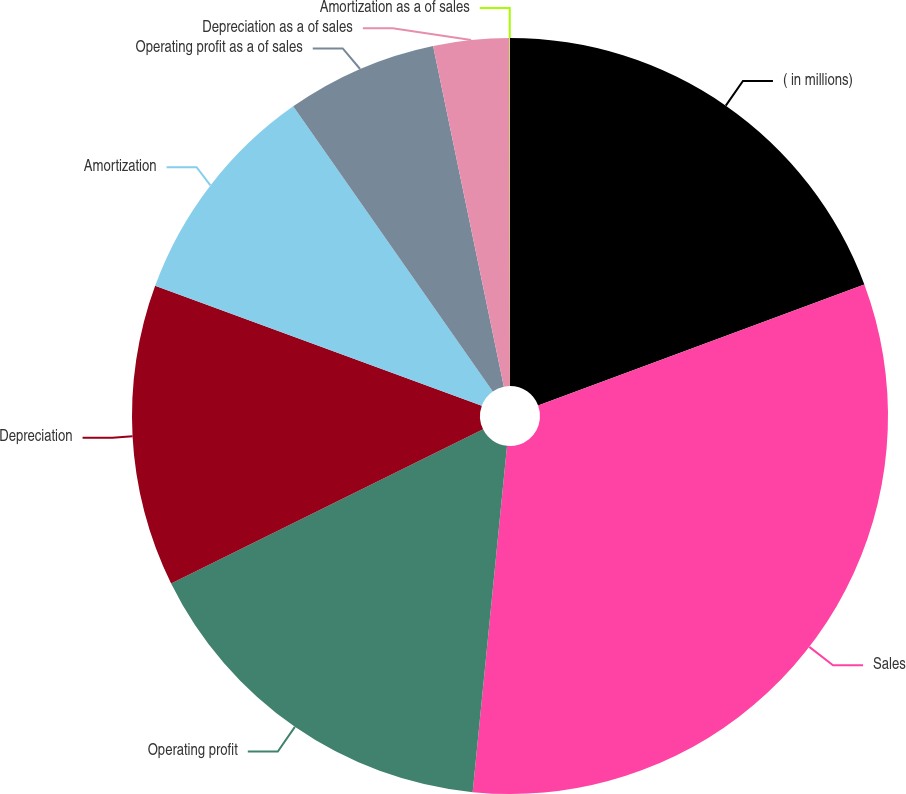<chart> <loc_0><loc_0><loc_500><loc_500><pie_chart><fcel>( in millions)<fcel>Sales<fcel>Operating profit<fcel>Depreciation<fcel>Amortization<fcel>Operating profit as a of sales<fcel>Depreciation as a of sales<fcel>Amortization as a of sales<nl><fcel>19.34%<fcel>32.23%<fcel>16.12%<fcel>12.9%<fcel>9.68%<fcel>6.46%<fcel>3.24%<fcel>0.02%<nl></chart> 